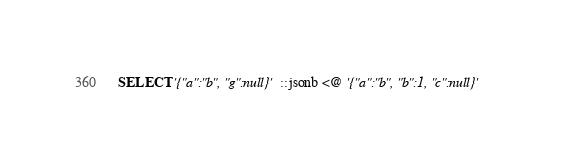Convert code to text. <code><loc_0><loc_0><loc_500><loc_500><_SQL_>SELECT '{"a":"b", "g":null}'::jsonb <@ '{"a":"b", "b":1, "c":null}'
</code> 